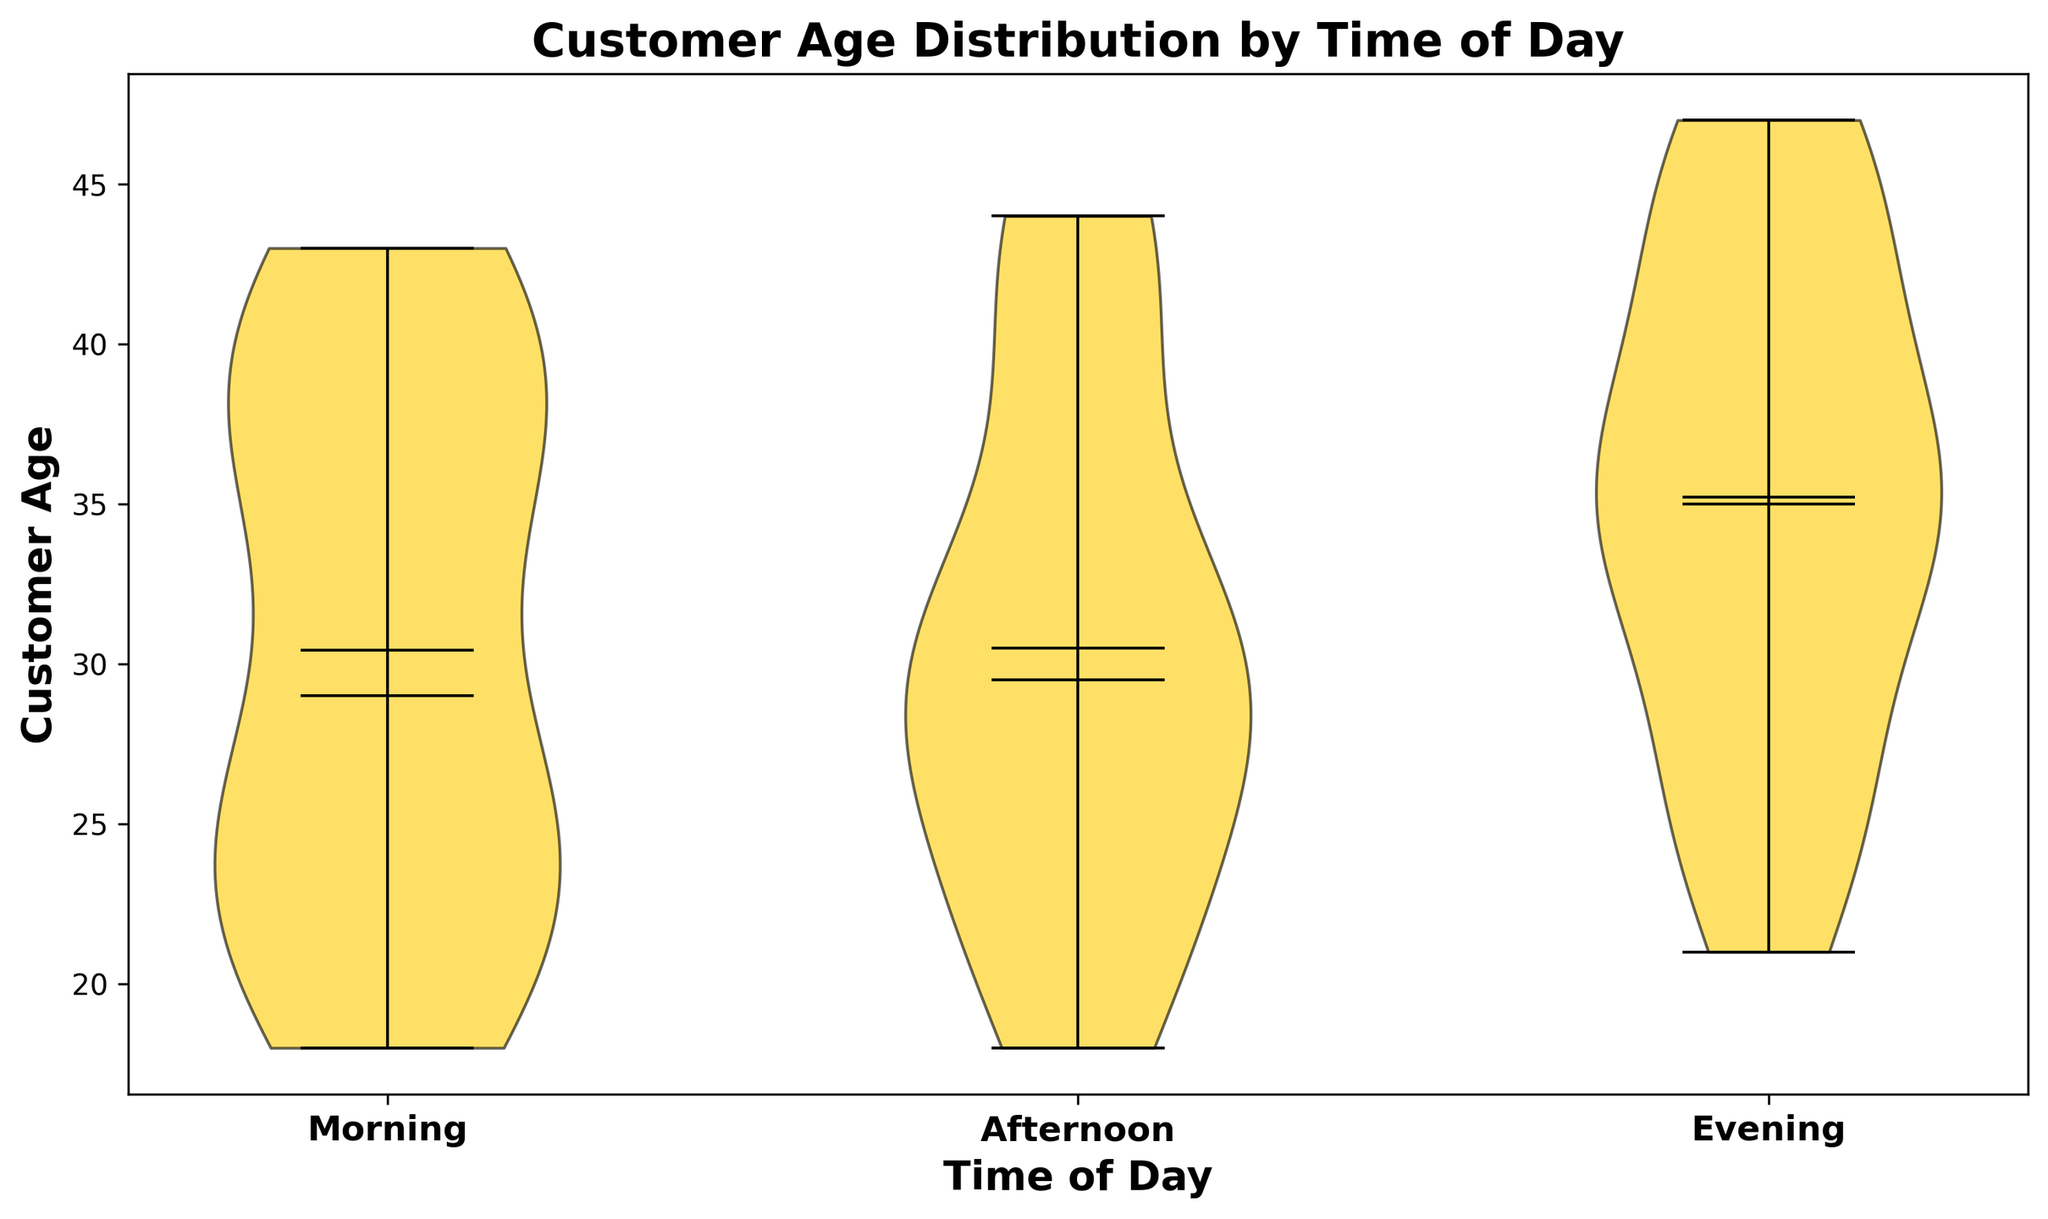Which time of day has the highest median customer age? Look at the central line within each "violin" shape, which represents the median. Identify which of the three time categories (Morning, Afternoon, Evening) has the highest position of this central line.
Answer: Evening How does the interquartile range compare between Morning and Afternoon customer ages? The interquartile range is the area between the top and bottom of the colored "violin" shapes around the median line. Compare the width of the shapes around the median for both Morning and Afternoon.
Answer: Morning has a narrower interquartile range than Afternoon What is the mean customer age for the Evening time? The mean is indicated by a small circle within each "violin" shape. Identify the position of this circle for the Evening category.
Answer: Around 37 Which time of day shows the widest distribution of customer ages? The widest violin shape indicates a wider distribution of ages. Compare the width of each "violin" across the Morning, Afternoon, and Evening categories.
Answer: Evening Are there any noticeable outliers in the customer age distribution for Morning? Outliers are typically marked by points outside the main "violin" shape. Look around the Morning category for any such points.
Answer: No What are the age ranges covered by the Morning and Evening distributions? The range is given by the ends of the whiskers in the "violin" plot. Identify these end points for both Morning and Evening categories.
Answer: Morning: 18-43, Evening: 21-47 Is the median customer age for Afternoon closer to Morning or Evening? Compare the median lines of all three time categories. Determine which median line for Afternoon is closer to, by height, to those of Morning or Evening.
Answer: Morning Which time of day has the most skewed customer age distribution? Skewness can be judged by the asymmetry of the "violin" shape around the median line. Identify which shape is more asymmetric in comparison to the others.
Answer: Evening How do the extremes (minimum and maximum ages) of Afternoon compare to those of Morning? The extremes are determined by the outermost points of the "violin" shapes. Compare these points between the Afternoon and Morning categories.
Answer: Afternoon has both a lower minimum (18 vs. 19) and higher maximum (44 vs. 43) Which two time periods have the most similar mean customer age? The mean is shown as small circles within the "violins." Compare the positions of these circles across all three categories. Identify the two closest in height.
Answer: Morning and Afternoon 